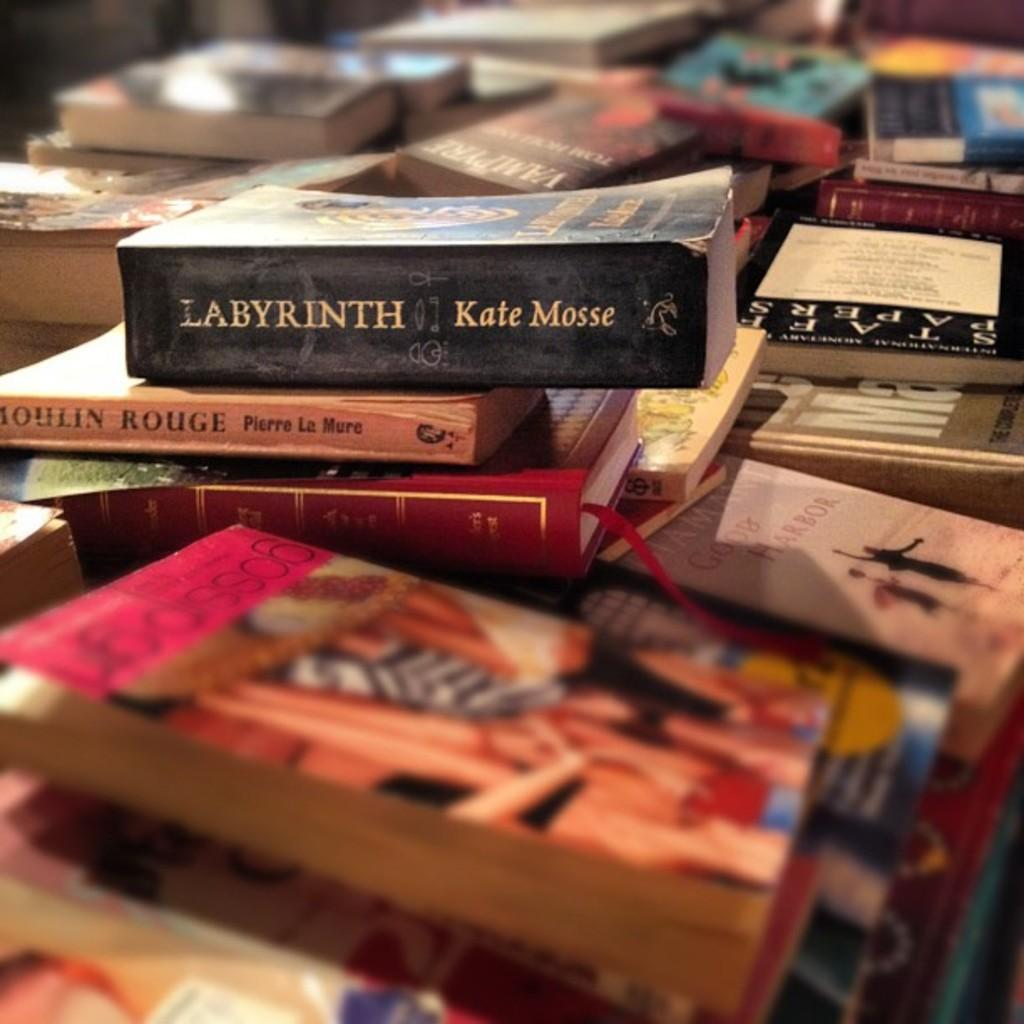<image>
Write a terse but informative summary of the picture. Book named Labyrinth written by Kate Mosse on top of a stack of other books. 